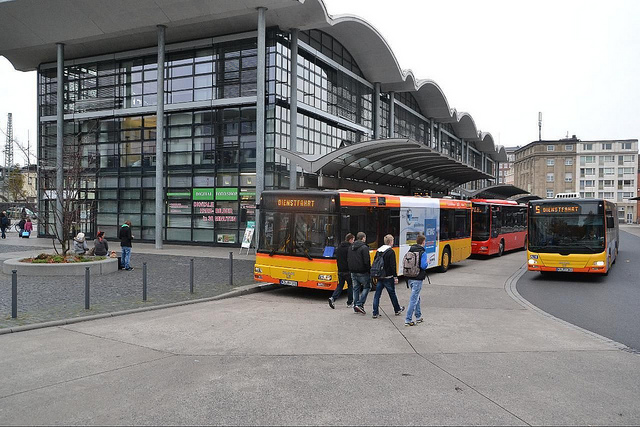What seems to be the function of the building behind the buses? The building behind the buses appears to be a bus station or transit hub, as indicated by its design featuring multiple bus bays and its proximity to the parked buses. 